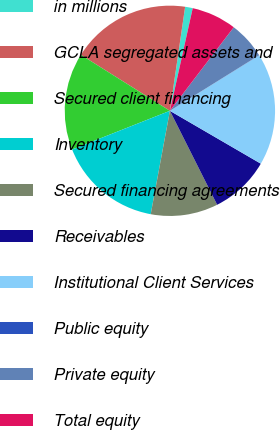Convert chart to OTSL. <chart><loc_0><loc_0><loc_500><loc_500><pie_chart><fcel>in millions<fcel>GCLA segregated assets and<fcel>Secured client financing<fcel>Inventory<fcel>Secured financing agreements<fcel>Receivables<fcel>Institutional Client Services<fcel>Public equity<fcel>Private equity<fcel>Total equity<nl><fcel>1.17%<fcel>18.38%<fcel>14.93%<fcel>16.08%<fcel>10.34%<fcel>9.2%<fcel>17.23%<fcel>0.02%<fcel>5.75%<fcel>6.9%<nl></chart> 